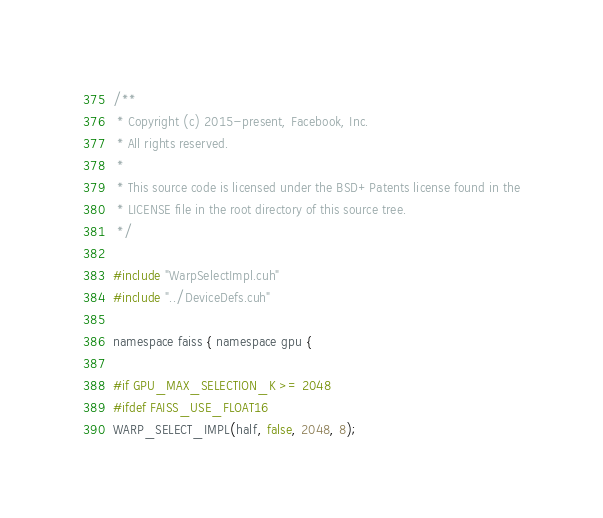Convert code to text. <code><loc_0><loc_0><loc_500><loc_500><_Cuda_>/**
 * Copyright (c) 2015-present, Facebook, Inc.
 * All rights reserved.
 *
 * This source code is licensed under the BSD+Patents license found in the
 * LICENSE file in the root directory of this source tree.
 */

#include "WarpSelectImpl.cuh"
#include "../DeviceDefs.cuh"

namespace faiss { namespace gpu {

#if GPU_MAX_SELECTION_K >= 2048
#ifdef FAISS_USE_FLOAT16
WARP_SELECT_IMPL(half, false, 2048, 8);</code> 